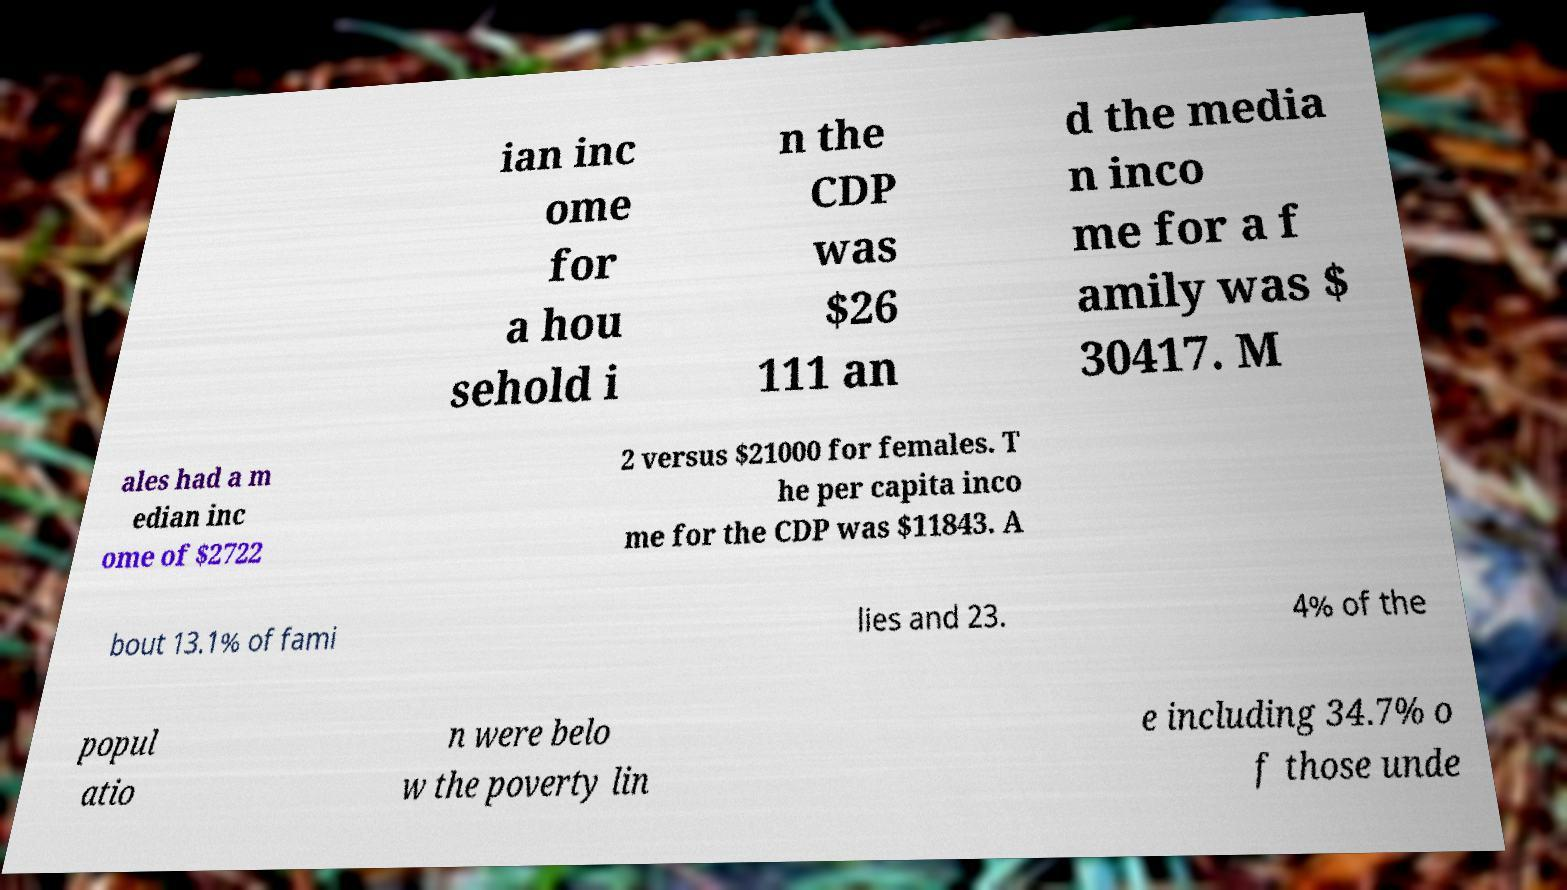Could you extract and type out the text from this image? ian inc ome for a hou sehold i n the CDP was $26 111 an d the media n inco me for a f amily was $ 30417. M ales had a m edian inc ome of $2722 2 versus $21000 for females. T he per capita inco me for the CDP was $11843. A bout 13.1% of fami lies and 23. 4% of the popul atio n were belo w the poverty lin e including 34.7% o f those unde 